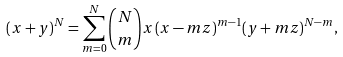<formula> <loc_0><loc_0><loc_500><loc_500>( x + y ) ^ { N } = \sum _ { m = 0 } ^ { N } { N \choose m } x \, ( x - m z ) ^ { m - 1 } ( y + m z ) ^ { N - m } ,</formula> 